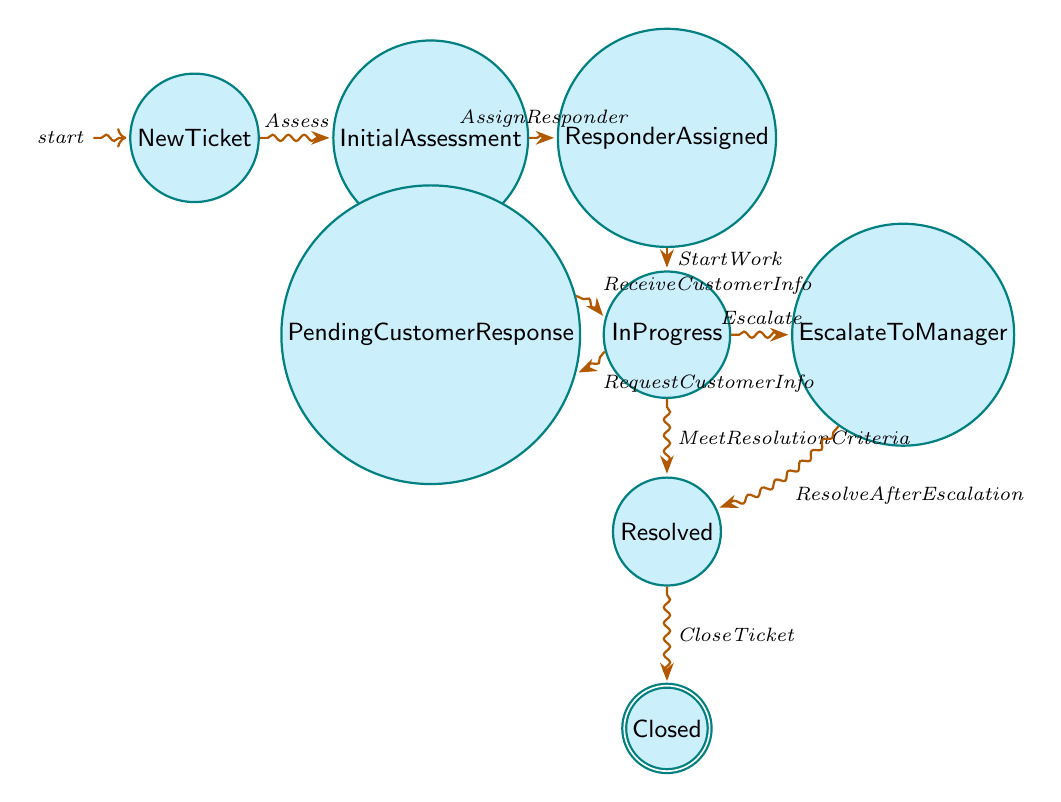What is the initial state of the ticket? The diagram starts with the node labeled "NewTicket," indicating that the ticket is in the initial state when created.
Answer: NewTicket How many states are there in the diagram? By counting the distinct nodes in the diagram, we find that there are a total of eight states representing different phases of the ticket escalation process.
Answer: Eight What is the transition from "InitialAssessment" to "ResponderAssigned"? The edge connecting these two nodes is labeled "AssignResponder," indicating that this action moves the ticket from assessment to assignment to a responder.
Answer: AssignResponder What happens after "InProgress" when the issue is resolved? According to the diagram, once the ticket in "InProgress" meets the resolution criteria, it transitions to the "Resolved" state.
Answer: Resolved What is the state the ticket enters after it receives customer information? The transition labeled "ReceiveCustomerInfo" indicates that after the ticket is in "PendingCustomerResponse," it returns to the "InProgress" state upon receiving the required information.
Answer: InProgress What are the two ways to move from "InProgress"? From "InProgress," the ticket can either go to "Resolved" by meeting resolution criteria or to "EscalateToManager" if it needs higher-level assistance, as indicated by the two outgoing edges from "InProgress."
Answer: Resolved, EscalateToManager What is the final state of a support ticket after it is resolved? The diagram shows that once a ticket is marked as "Resolved," it can then be transitioned to the "Closed" state, indicating the completion of the process.
Answer: Closed How does the escalation to a manager occur in the process? The transition labeled "Escalate" demonstrates that if the ticket's complexity or priority demands attention, it moves from "InProgress" to "EscalateToManager," indicating escalation.
Answer: EscalateToManager 